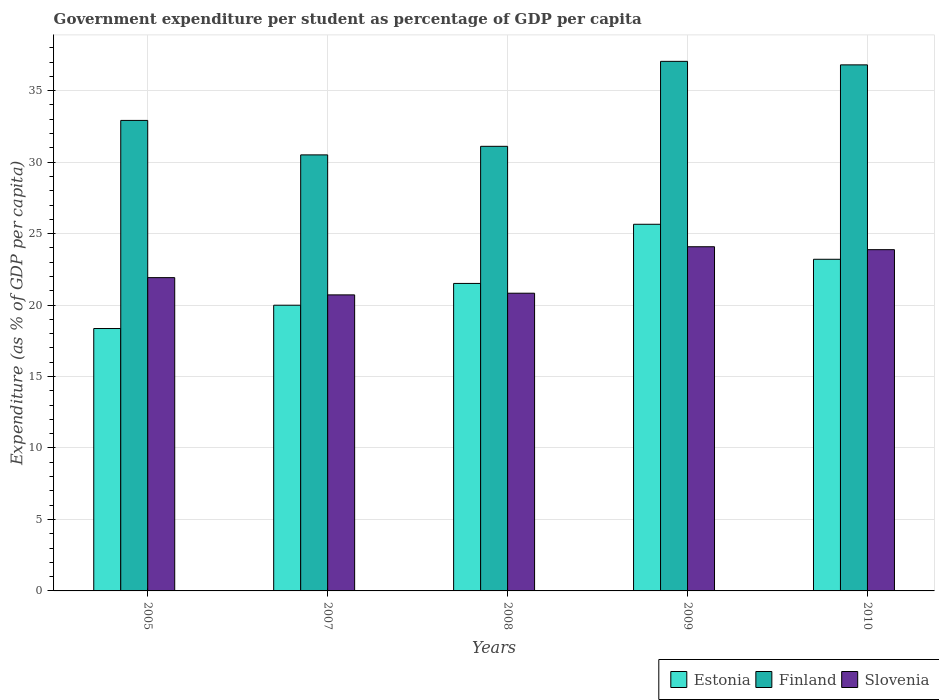How many different coloured bars are there?
Give a very brief answer. 3. How many groups of bars are there?
Your response must be concise. 5. Are the number of bars on each tick of the X-axis equal?
Your answer should be compact. Yes. What is the label of the 4th group of bars from the left?
Provide a short and direct response. 2009. What is the percentage of expenditure per student in Estonia in 2007?
Ensure brevity in your answer.  19.99. Across all years, what is the maximum percentage of expenditure per student in Estonia?
Your answer should be very brief. 25.65. Across all years, what is the minimum percentage of expenditure per student in Slovenia?
Your answer should be very brief. 20.71. In which year was the percentage of expenditure per student in Estonia maximum?
Keep it short and to the point. 2009. In which year was the percentage of expenditure per student in Estonia minimum?
Provide a short and direct response. 2005. What is the total percentage of expenditure per student in Estonia in the graph?
Keep it short and to the point. 108.72. What is the difference between the percentage of expenditure per student in Finland in 2007 and that in 2009?
Offer a terse response. -6.54. What is the difference between the percentage of expenditure per student in Slovenia in 2008 and the percentage of expenditure per student in Finland in 2010?
Your answer should be very brief. -15.98. What is the average percentage of expenditure per student in Slovenia per year?
Make the answer very short. 22.28. In the year 2007, what is the difference between the percentage of expenditure per student in Slovenia and percentage of expenditure per student in Finland?
Give a very brief answer. -9.79. In how many years, is the percentage of expenditure per student in Estonia greater than 26 %?
Your answer should be compact. 0. What is the ratio of the percentage of expenditure per student in Estonia in 2007 to that in 2008?
Give a very brief answer. 0.93. Is the percentage of expenditure per student in Finland in 2009 less than that in 2010?
Your answer should be compact. No. What is the difference between the highest and the second highest percentage of expenditure per student in Finland?
Your answer should be compact. 0.25. What is the difference between the highest and the lowest percentage of expenditure per student in Finland?
Your answer should be compact. 6.54. Is the sum of the percentage of expenditure per student in Slovenia in 2005 and 2010 greater than the maximum percentage of expenditure per student in Finland across all years?
Make the answer very short. Yes. What does the 2nd bar from the left in 2007 represents?
Your answer should be compact. Finland. What does the 1st bar from the right in 2010 represents?
Make the answer very short. Slovenia. Is it the case that in every year, the sum of the percentage of expenditure per student in Finland and percentage of expenditure per student in Slovenia is greater than the percentage of expenditure per student in Estonia?
Make the answer very short. Yes. Are all the bars in the graph horizontal?
Provide a short and direct response. No. How many years are there in the graph?
Make the answer very short. 5. Are the values on the major ticks of Y-axis written in scientific E-notation?
Provide a succinct answer. No. Where does the legend appear in the graph?
Provide a short and direct response. Bottom right. How many legend labels are there?
Offer a very short reply. 3. How are the legend labels stacked?
Give a very brief answer. Horizontal. What is the title of the graph?
Your answer should be very brief. Government expenditure per student as percentage of GDP per capita. What is the label or title of the Y-axis?
Your answer should be very brief. Expenditure (as % of GDP per capita). What is the Expenditure (as % of GDP per capita) of Estonia in 2005?
Offer a terse response. 18.36. What is the Expenditure (as % of GDP per capita) of Finland in 2005?
Your response must be concise. 32.92. What is the Expenditure (as % of GDP per capita) of Slovenia in 2005?
Give a very brief answer. 21.92. What is the Expenditure (as % of GDP per capita) of Estonia in 2007?
Keep it short and to the point. 19.99. What is the Expenditure (as % of GDP per capita) in Finland in 2007?
Your response must be concise. 30.51. What is the Expenditure (as % of GDP per capita) in Slovenia in 2007?
Ensure brevity in your answer.  20.71. What is the Expenditure (as % of GDP per capita) in Estonia in 2008?
Offer a very short reply. 21.51. What is the Expenditure (as % of GDP per capita) in Finland in 2008?
Offer a terse response. 31.11. What is the Expenditure (as % of GDP per capita) of Slovenia in 2008?
Your response must be concise. 20.83. What is the Expenditure (as % of GDP per capita) in Estonia in 2009?
Your response must be concise. 25.65. What is the Expenditure (as % of GDP per capita) of Finland in 2009?
Provide a short and direct response. 37.05. What is the Expenditure (as % of GDP per capita) in Slovenia in 2009?
Your answer should be very brief. 24.08. What is the Expenditure (as % of GDP per capita) in Estonia in 2010?
Your answer should be compact. 23.2. What is the Expenditure (as % of GDP per capita) of Finland in 2010?
Your answer should be compact. 36.8. What is the Expenditure (as % of GDP per capita) of Slovenia in 2010?
Your answer should be compact. 23.88. Across all years, what is the maximum Expenditure (as % of GDP per capita) in Estonia?
Make the answer very short. 25.65. Across all years, what is the maximum Expenditure (as % of GDP per capita) in Finland?
Your response must be concise. 37.05. Across all years, what is the maximum Expenditure (as % of GDP per capita) in Slovenia?
Provide a succinct answer. 24.08. Across all years, what is the minimum Expenditure (as % of GDP per capita) in Estonia?
Offer a terse response. 18.36. Across all years, what is the minimum Expenditure (as % of GDP per capita) of Finland?
Your answer should be very brief. 30.51. Across all years, what is the minimum Expenditure (as % of GDP per capita) of Slovenia?
Provide a short and direct response. 20.71. What is the total Expenditure (as % of GDP per capita) of Estonia in the graph?
Your answer should be very brief. 108.72. What is the total Expenditure (as % of GDP per capita) of Finland in the graph?
Give a very brief answer. 168.38. What is the total Expenditure (as % of GDP per capita) in Slovenia in the graph?
Provide a short and direct response. 111.41. What is the difference between the Expenditure (as % of GDP per capita) in Estonia in 2005 and that in 2007?
Your answer should be very brief. -1.63. What is the difference between the Expenditure (as % of GDP per capita) in Finland in 2005 and that in 2007?
Make the answer very short. 2.41. What is the difference between the Expenditure (as % of GDP per capita) of Slovenia in 2005 and that in 2007?
Offer a very short reply. 1.21. What is the difference between the Expenditure (as % of GDP per capita) in Estonia in 2005 and that in 2008?
Offer a terse response. -3.16. What is the difference between the Expenditure (as % of GDP per capita) in Finland in 2005 and that in 2008?
Your response must be concise. 1.81. What is the difference between the Expenditure (as % of GDP per capita) in Slovenia in 2005 and that in 2008?
Provide a short and direct response. 1.09. What is the difference between the Expenditure (as % of GDP per capita) in Estonia in 2005 and that in 2009?
Offer a terse response. -7.29. What is the difference between the Expenditure (as % of GDP per capita) of Finland in 2005 and that in 2009?
Your answer should be compact. -4.13. What is the difference between the Expenditure (as % of GDP per capita) in Slovenia in 2005 and that in 2009?
Make the answer very short. -2.16. What is the difference between the Expenditure (as % of GDP per capita) of Estonia in 2005 and that in 2010?
Provide a succinct answer. -4.85. What is the difference between the Expenditure (as % of GDP per capita) in Finland in 2005 and that in 2010?
Ensure brevity in your answer.  -3.89. What is the difference between the Expenditure (as % of GDP per capita) in Slovenia in 2005 and that in 2010?
Your answer should be very brief. -1.96. What is the difference between the Expenditure (as % of GDP per capita) in Estonia in 2007 and that in 2008?
Make the answer very short. -1.52. What is the difference between the Expenditure (as % of GDP per capita) of Finland in 2007 and that in 2008?
Offer a very short reply. -0.6. What is the difference between the Expenditure (as % of GDP per capita) of Slovenia in 2007 and that in 2008?
Give a very brief answer. -0.12. What is the difference between the Expenditure (as % of GDP per capita) in Estonia in 2007 and that in 2009?
Your answer should be very brief. -5.66. What is the difference between the Expenditure (as % of GDP per capita) in Finland in 2007 and that in 2009?
Offer a very short reply. -6.54. What is the difference between the Expenditure (as % of GDP per capita) in Slovenia in 2007 and that in 2009?
Make the answer very short. -3.37. What is the difference between the Expenditure (as % of GDP per capita) in Estonia in 2007 and that in 2010?
Keep it short and to the point. -3.21. What is the difference between the Expenditure (as % of GDP per capita) of Finland in 2007 and that in 2010?
Keep it short and to the point. -6.3. What is the difference between the Expenditure (as % of GDP per capita) of Slovenia in 2007 and that in 2010?
Give a very brief answer. -3.16. What is the difference between the Expenditure (as % of GDP per capita) of Estonia in 2008 and that in 2009?
Your answer should be compact. -4.14. What is the difference between the Expenditure (as % of GDP per capita) in Finland in 2008 and that in 2009?
Your answer should be very brief. -5.94. What is the difference between the Expenditure (as % of GDP per capita) of Slovenia in 2008 and that in 2009?
Offer a terse response. -3.25. What is the difference between the Expenditure (as % of GDP per capita) of Estonia in 2008 and that in 2010?
Your answer should be very brief. -1.69. What is the difference between the Expenditure (as % of GDP per capita) in Finland in 2008 and that in 2010?
Offer a terse response. -5.7. What is the difference between the Expenditure (as % of GDP per capita) in Slovenia in 2008 and that in 2010?
Your answer should be very brief. -3.05. What is the difference between the Expenditure (as % of GDP per capita) in Estonia in 2009 and that in 2010?
Your answer should be compact. 2.45. What is the difference between the Expenditure (as % of GDP per capita) in Finland in 2009 and that in 2010?
Your response must be concise. 0.25. What is the difference between the Expenditure (as % of GDP per capita) of Slovenia in 2009 and that in 2010?
Your answer should be very brief. 0.2. What is the difference between the Expenditure (as % of GDP per capita) of Estonia in 2005 and the Expenditure (as % of GDP per capita) of Finland in 2007?
Give a very brief answer. -12.15. What is the difference between the Expenditure (as % of GDP per capita) of Estonia in 2005 and the Expenditure (as % of GDP per capita) of Slovenia in 2007?
Provide a succinct answer. -2.35. What is the difference between the Expenditure (as % of GDP per capita) in Finland in 2005 and the Expenditure (as % of GDP per capita) in Slovenia in 2007?
Keep it short and to the point. 12.21. What is the difference between the Expenditure (as % of GDP per capita) of Estonia in 2005 and the Expenditure (as % of GDP per capita) of Finland in 2008?
Your answer should be compact. -12.75. What is the difference between the Expenditure (as % of GDP per capita) in Estonia in 2005 and the Expenditure (as % of GDP per capita) in Slovenia in 2008?
Keep it short and to the point. -2.47. What is the difference between the Expenditure (as % of GDP per capita) of Finland in 2005 and the Expenditure (as % of GDP per capita) of Slovenia in 2008?
Offer a very short reply. 12.09. What is the difference between the Expenditure (as % of GDP per capita) of Estonia in 2005 and the Expenditure (as % of GDP per capita) of Finland in 2009?
Keep it short and to the point. -18.69. What is the difference between the Expenditure (as % of GDP per capita) of Estonia in 2005 and the Expenditure (as % of GDP per capita) of Slovenia in 2009?
Make the answer very short. -5.72. What is the difference between the Expenditure (as % of GDP per capita) in Finland in 2005 and the Expenditure (as % of GDP per capita) in Slovenia in 2009?
Your response must be concise. 8.84. What is the difference between the Expenditure (as % of GDP per capita) in Estonia in 2005 and the Expenditure (as % of GDP per capita) in Finland in 2010?
Keep it short and to the point. -18.45. What is the difference between the Expenditure (as % of GDP per capita) in Estonia in 2005 and the Expenditure (as % of GDP per capita) in Slovenia in 2010?
Ensure brevity in your answer.  -5.52. What is the difference between the Expenditure (as % of GDP per capita) of Finland in 2005 and the Expenditure (as % of GDP per capita) of Slovenia in 2010?
Offer a very short reply. 9.04. What is the difference between the Expenditure (as % of GDP per capita) of Estonia in 2007 and the Expenditure (as % of GDP per capita) of Finland in 2008?
Provide a short and direct response. -11.12. What is the difference between the Expenditure (as % of GDP per capita) of Estonia in 2007 and the Expenditure (as % of GDP per capita) of Slovenia in 2008?
Ensure brevity in your answer.  -0.84. What is the difference between the Expenditure (as % of GDP per capita) in Finland in 2007 and the Expenditure (as % of GDP per capita) in Slovenia in 2008?
Offer a very short reply. 9.68. What is the difference between the Expenditure (as % of GDP per capita) in Estonia in 2007 and the Expenditure (as % of GDP per capita) in Finland in 2009?
Give a very brief answer. -17.06. What is the difference between the Expenditure (as % of GDP per capita) in Estonia in 2007 and the Expenditure (as % of GDP per capita) in Slovenia in 2009?
Give a very brief answer. -4.09. What is the difference between the Expenditure (as % of GDP per capita) in Finland in 2007 and the Expenditure (as % of GDP per capita) in Slovenia in 2009?
Your answer should be compact. 6.43. What is the difference between the Expenditure (as % of GDP per capita) in Estonia in 2007 and the Expenditure (as % of GDP per capita) in Finland in 2010?
Your answer should be very brief. -16.81. What is the difference between the Expenditure (as % of GDP per capita) of Estonia in 2007 and the Expenditure (as % of GDP per capita) of Slovenia in 2010?
Give a very brief answer. -3.89. What is the difference between the Expenditure (as % of GDP per capita) in Finland in 2007 and the Expenditure (as % of GDP per capita) in Slovenia in 2010?
Provide a succinct answer. 6.63. What is the difference between the Expenditure (as % of GDP per capita) of Estonia in 2008 and the Expenditure (as % of GDP per capita) of Finland in 2009?
Make the answer very short. -15.54. What is the difference between the Expenditure (as % of GDP per capita) in Estonia in 2008 and the Expenditure (as % of GDP per capita) in Slovenia in 2009?
Provide a short and direct response. -2.57. What is the difference between the Expenditure (as % of GDP per capita) of Finland in 2008 and the Expenditure (as % of GDP per capita) of Slovenia in 2009?
Your response must be concise. 7.03. What is the difference between the Expenditure (as % of GDP per capita) in Estonia in 2008 and the Expenditure (as % of GDP per capita) in Finland in 2010?
Your response must be concise. -15.29. What is the difference between the Expenditure (as % of GDP per capita) in Estonia in 2008 and the Expenditure (as % of GDP per capita) in Slovenia in 2010?
Keep it short and to the point. -2.36. What is the difference between the Expenditure (as % of GDP per capita) in Finland in 2008 and the Expenditure (as % of GDP per capita) in Slovenia in 2010?
Offer a very short reply. 7.23. What is the difference between the Expenditure (as % of GDP per capita) of Estonia in 2009 and the Expenditure (as % of GDP per capita) of Finland in 2010?
Give a very brief answer. -11.15. What is the difference between the Expenditure (as % of GDP per capita) of Estonia in 2009 and the Expenditure (as % of GDP per capita) of Slovenia in 2010?
Provide a succinct answer. 1.78. What is the difference between the Expenditure (as % of GDP per capita) of Finland in 2009 and the Expenditure (as % of GDP per capita) of Slovenia in 2010?
Provide a short and direct response. 13.17. What is the average Expenditure (as % of GDP per capita) of Estonia per year?
Keep it short and to the point. 21.74. What is the average Expenditure (as % of GDP per capita) of Finland per year?
Your response must be concise. 33.68. What is the average Expenditure (as % of GDP per capita) in Slovenia per year?
Provide a succinct answer. 22.28. In the year 2005, what is the difference between the Expenditure (as % of GDP per capita) in Estonia and Expenditure (as % of GDP per capita) in Finland?
Provide a succinct answer. -14.56. In the year 2005, what is the difference between the Expenditure (as % of GDP per capita) of Estonia and Expenditure (as % of GDP per capita) of Slovenia?
Provide a short and direct response. -3.56. In the year 2005, what is the difference between the Expenditure (as % of GDP per capita) of Finland and Expenditure (as % of GDP per capita) of Slovenia?
Your response must be concise. 11. In the year 2007, what is the difference between the Expenditure (as % of GDP per capita) of Estonia and Expenditure (as % of GDP per capita) of Finland?
Make the answer very short. -10.52. In the year 2007, what is the difference between the Expenditure (as % of GDP per capita) of Estonia and Expenditure (as % of GDP per capita) of Slovenia?
Give a very brief answer. -0.72. In the year 2007, what is the difference between the Expenditure (as % of GDP per capita) of Finland and Expenditure (as % of GDP per capita) of Slovenia?
Give a very brief answer. 9.79. In the year 2008, what is the difference between the Expenditure (as % of GDP per capita) in Estonia and Expenditure (as % of GDP per capita) in Finland?
Your answer should be compact. -9.59. In the year 2008, what is the difference between the Expenditure (as % of GDP per capita) in Estonia and Expenditure (as % of GDP per capita) in Slovenia?
Offer a terse response. 0.68. In the year 2008, what is the difference between the Expenditure (as % of GDP per capita) in Finland and Expenditure (as % of GDP per capita) in Slovenia?
Your response must be concise. 10.28. In the year 2009, what is the difference between the Expenditure (as % of GDP per capita) in Estonia and Expenditure (as % of GDP per capita) in Finland?
Your response must be concise. -11.4. In the year 2009, what is the difference between the Expenditure (as % of GDP per capita) of Estonia and Expenditure (as % of GDP per capita) of Slovenia?
Your response must be concise. 1.57. In the year 2009, what is the difference between the Expenditure (as % of GDP per capita) of Finland and Expenditure (as % of GDP per capita) of Slovenia?
Ensure brevity in your answer.  12.97. In the year 2010, what is the difference between the Expenditure (as % of GDP per capita) in Estonia and Expenditure (as % of GDP per capita) in Finland?
Ensure brevity in your answer.  -13.6. In the year 2010, what is the difference between the Expenditure (as % of GDP per capita) of Estonia and Expenditure (as % of GDP per capita) of Slovenia?
Offer a terse response. -0.67. In the year 2010, what is the difference between the Expenditure (as % of GDP per capita) in Finland and Expenditure (as % of GDP per capita) in Slovenia?
Offer a terse response. 12.93. What is the ratio of the Expenditure (as % of GDP per capita) in Estonia in 2005 to that in 2007?
Ensure brevity in your answer.  0.92. What is the ratio of the Expenditure (as % of GDP per capita) in Finland in 2005 to that in 2007?
Offer a very short reply. 1.08. What is the ratio of the Expenditure (as % of GDP per capita) in Slovenia in 2005 to that in 2007?
Provide a short and direct response. 1.06. What is the ratio of the Expenditure (as % of GDP per capita) in Estonia in 2005 to that in 2008?
Ensure brevity in your answer.  0.85. What is the ratio of the Expenditure (as % of GDP per capita) in Finland in 2005 to that in 2008?
Ensure brevity in your answer.  1.06. What is the ratio of the Expenditure (as % of GDP per capita) in Slovenia in 2005 to that in 2008?
Give a very brief answer. 1.05. What is the ratio of the Expenditure (as % of GDP per capita) of Estonia in 2005 to that in 2009?
Ensure brevity in your answer.  0.72. What is the ratio of the Expenditure (as % of GDP per capita) in Finland in 2005 to that in 2009?
Your answer should be compact. 0.89. What is the ratio of the Expenditure (as % of GDP per capita) in Slovenia in 2005 to that in 2009?
Make the answer very short. 0.91. What is the ratio of the Expenditure (as % of GDP per capita) in Estonia in 2005 to that in 2010?
Make the answer very short. 0.79. What is the ratio of the Expenditure (as % of GDP per capita) of Finland in 2005 to that in 2010?
Your answer should be compact. 0.89. What is the ratio of the Expenditure (as % of GDP per capita) in Slovenia in 2005 to that in 2010?
Offer a terse response. 0.92. What is the ratio of the Expenditure (as % of GDP per capita) of Estonia in 2007 to that in 2008?
Your response must be concise. 0.93. What is the ratio of the Expenditure (as % of GDP per capita) in Finland in 2007 to that in 2008?
Make the answer very short. 0.98. What is the ratio of the Expenditure (as % of GDP per capita) of Estonia in 2007 to that in 2009?
Your answer should be very brief. 0.78. What is the ratio of the Expenditure (as % of GDP per capita) in Finland in 2007 to that in 2009?
Give a very brief answer. 0.82. What is the ratio of the Expenditure (as % of GDP per capita) of Slovenia in 2007 to that in 2009?
Your response must be concise. 0.86. What is the ratio of the Expenditure (as % of GDP per capita) in Estonia in 2007 to that in 2010?
Ensure brevity in your answer.  0.86. What is the ratio of the Expenditure (as % of GDP per capita) of Finland in 2007 to that in 2010?
Provide a short and direct response. 0.83. What is the ratio of the Expenditure (as % of GDP per capita) of Slovenia in 2007 to that in 2010?
Your answer should be very brief. 0.87. What is the ratio of the Expenditure (as % of GDP per capita) of Estonia in 2008 to that in 2009?
Your answer should be very brief. 0.84. What is the ratio of the Expenditure (as % of GDP per capita) in Finland in 2008 to that in 2009?
Your answer should be compact. 0.84. What is the ratio of the Expenditure (as % of GDP per capita) in Slovenia in 2008 to that in 2009?
Ensure brevity in your answer.  0.86. What is the ratio of the Expenditure (as % of GDP per capita) of Estonia in 2008 to that in 2010?
Your response must be concise. 0.93. What is the ratio of the Expenditure (as % of GDP per capita) in Finland in 2008 to that in 2010?
Your answer should be compact. 0.85. What is the ratio of the Expenditure (as % of GDP per capita) in Slovenia in 2008 to that in 2010?
Provide a succinct answer. 0.87. What is the ratio of the Expenditure (as % of GDP per capita) in Estonia in 2009 to that in 2010?
Your answer should be very brief. 1.11. What is the ratio of the Expenditure (as % of GDP per capita) of Finland in 2009 to that in 2010?
Keep it short and to the point. 1.01. What is the ratio of the Expenditure (as % of GDP per capita) in Slovenia in 2009 to that in 2010?
Keep it short and to the point. 1.01. What is the difference between the highest and the second highest Expenditure (as % of GDP per capita) in Estonia?
Make the answer very short. 2.45. What is the difference between the highest and the second highest Expenditure (as % of GDP per capita) of Finland?
Make the answer very short. 0.25. What is the difference between the highest and the second highest Expenditure (as % of GDP per capita) of Slovenia?
Provide a short and direct response. 0.2. What is the difference between the highest and the lowest Expenditure (as % of GDP per capita) of Estonia?
Keep it short and to the point. 7.29. What is the difference between the highest and the lowest Expenditure (as % of GDP per capita) in Finland?
Give a very brief answer. 6.54. What is the difference between the highest and the lowest Expenditure (as % of GDP per capita) of Slovenia?
Keep it short and to the point. 3.37. 